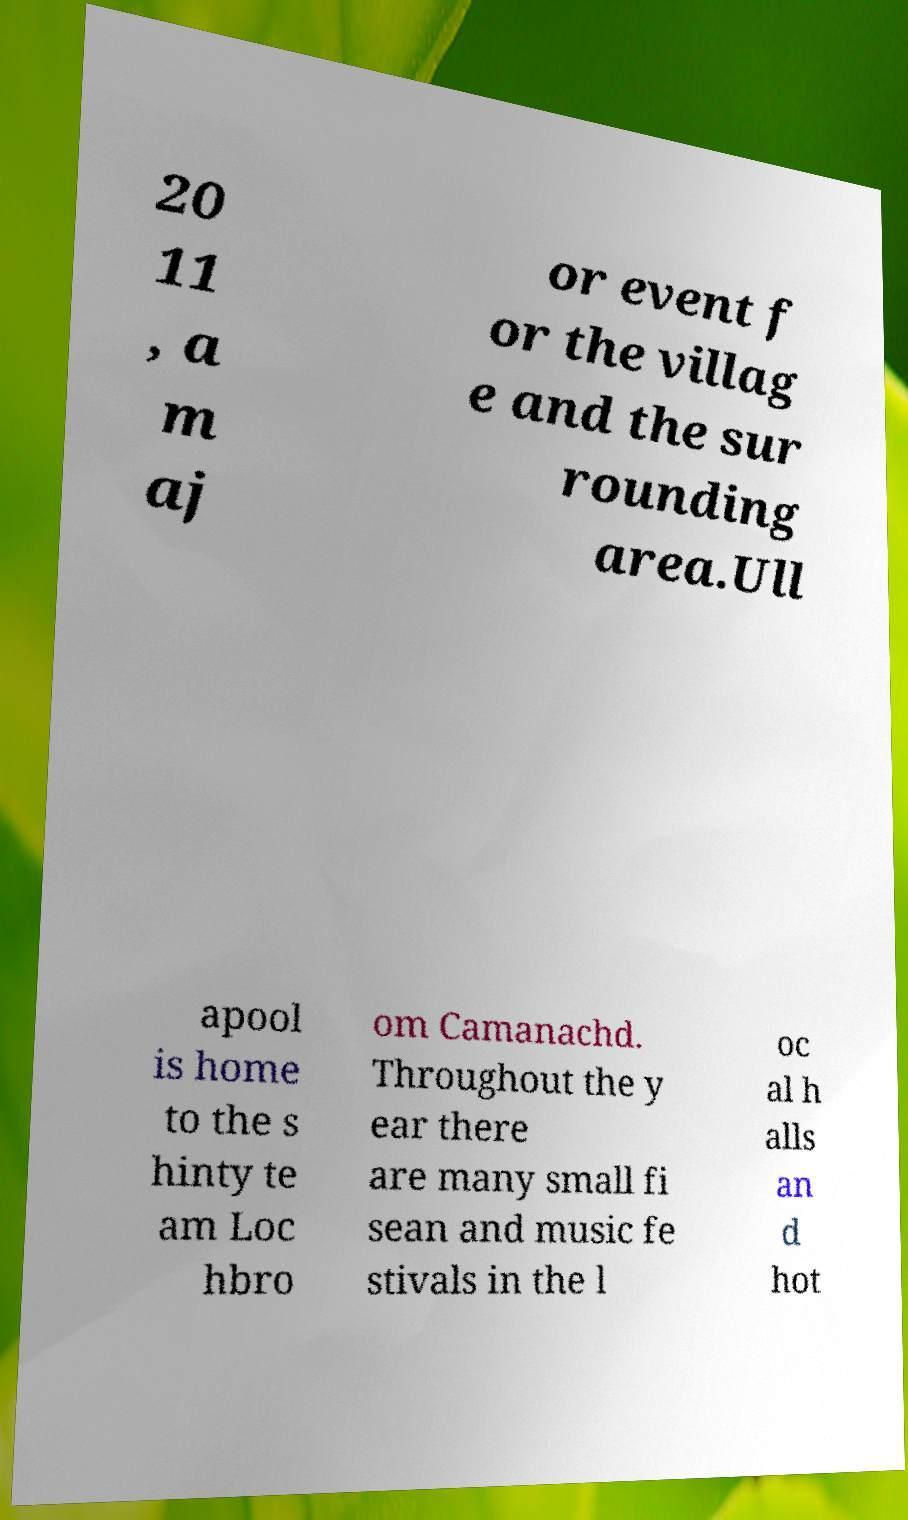Please identify and transcribe the text found in this image. 20 11 , a m aj or event f or the villag e and the sur rounding area.Ull apool is home to the s hinty te am Loc hbro om Camanachd. Throughout the y ear there are many small fi sean and music fe stivals in the l oc al h alls an d hot 